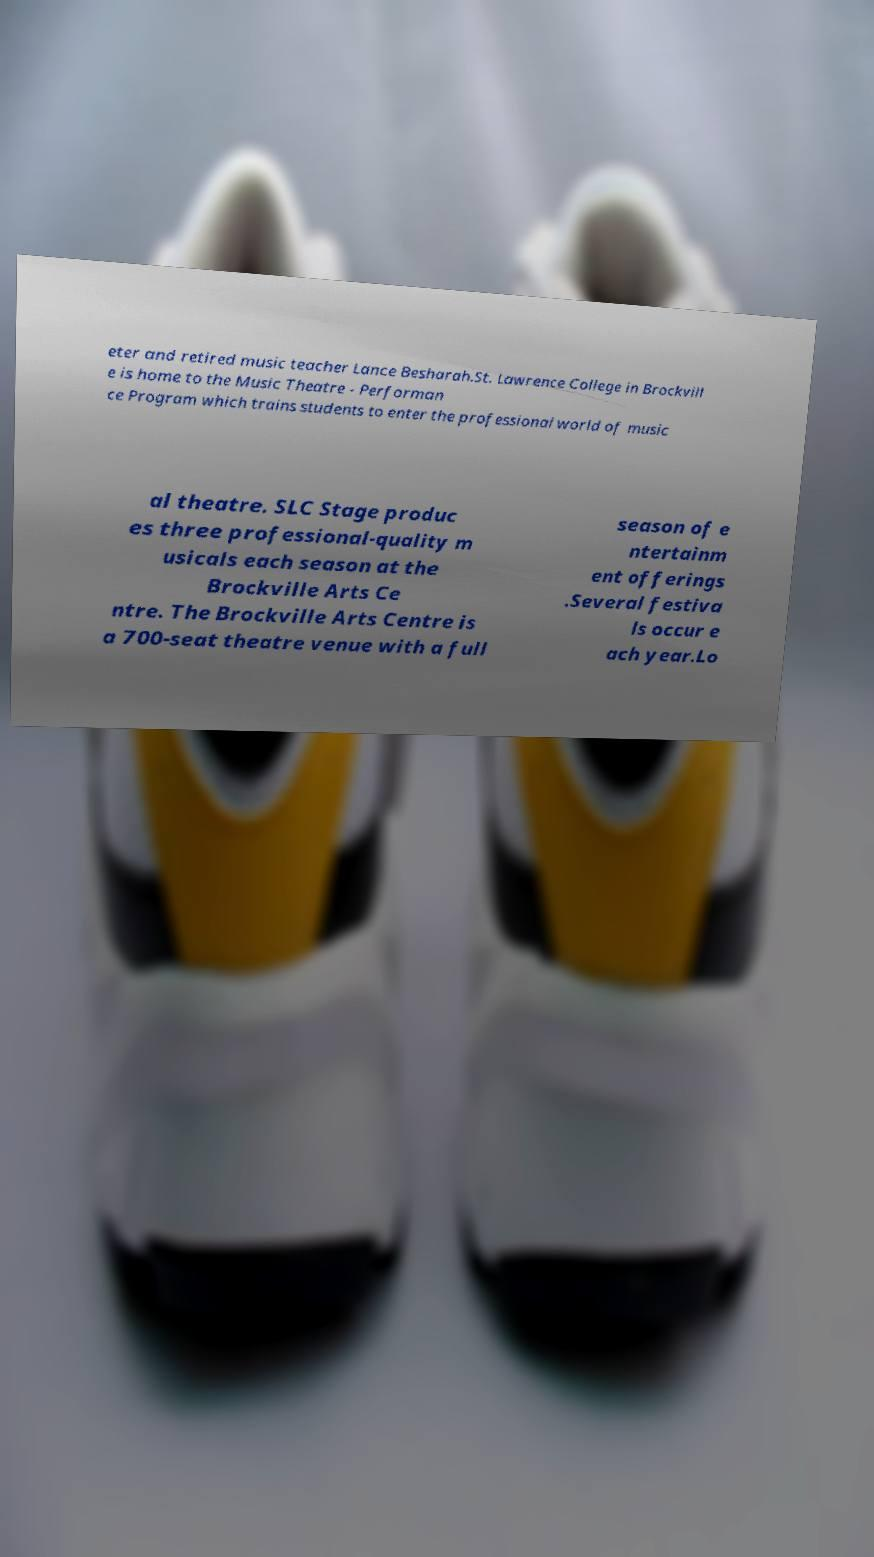Could you assist in decoding the text presented in this image and type it out clearly? eter and retired music teacher Lance Besharah.St. Lawrence College in Brockvill e is home to the Music Theatre - Performan ce Program which trains students to enter the professional world of music al theatre. SLC Stage produc es three professional-quality m usicals each season at the Brockville Arts Ce ntre. The Brockville Arts Centre is a 700-seat theatre venue with a full season of e ntertainm ent offerings .Several festiva ls occur e ach year.Lo 